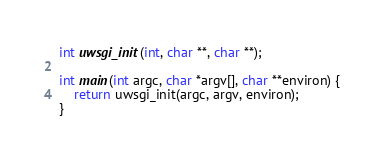<code> <loc_0><loc_0><loc_500><loc_500><_C_>int uwsgi_init(int, char **, char **);

int main(int argc, char *argv[], char **environ) {
	return uwsgi_init(argc, argv, environ);
}
</code> 